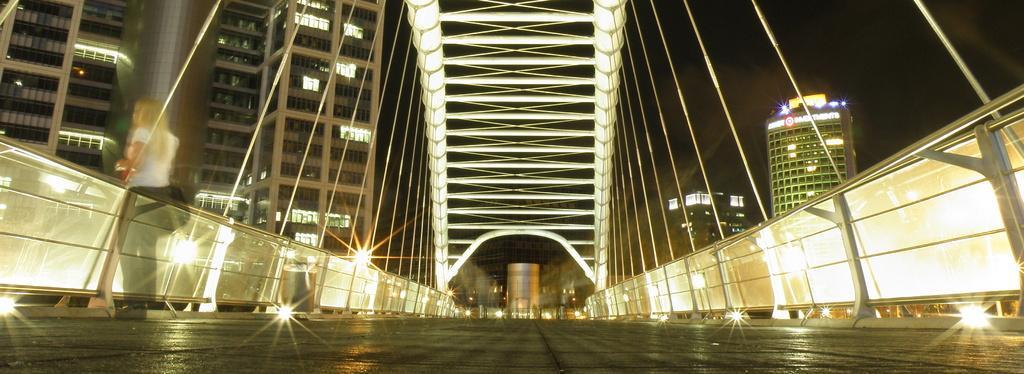Could you give a brief overview of what you see in this image? In this image I can see the road. To the side of the road there is a railing. In the background I can see many building and lights. I can also see the sky in the back. 